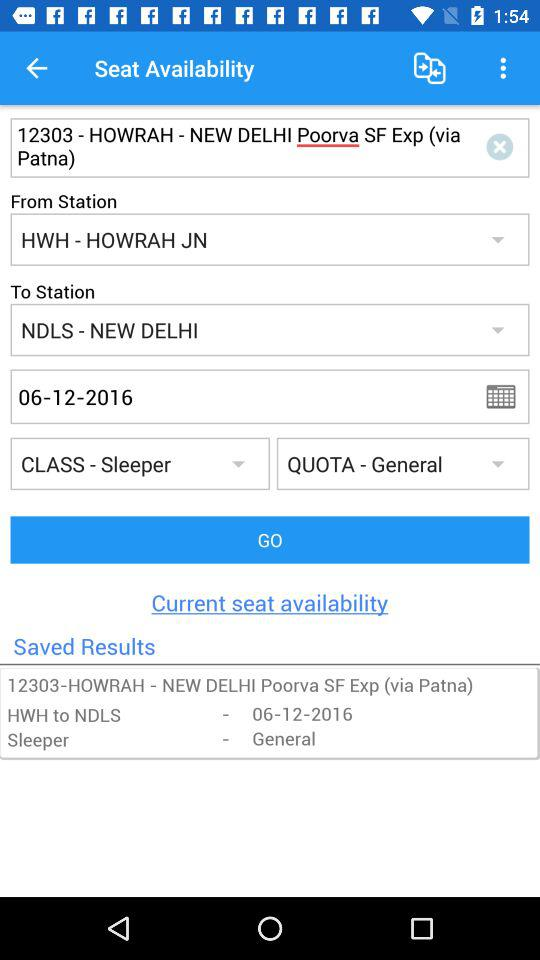What is the departure date? The departure date is December 6, 2016. 